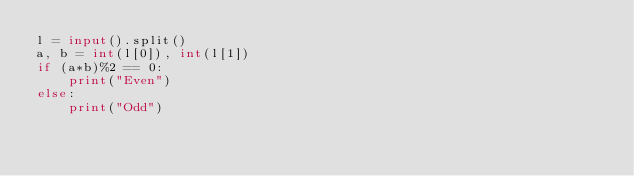<code> <loc_0><loc_0><loc_500><loc_500><_Python_>l = input().split()
a, b = int(l[0]), int(l[1])
if (a*b)%2 == 0:
	print("Even")
else:
	print("Odd")</code> 